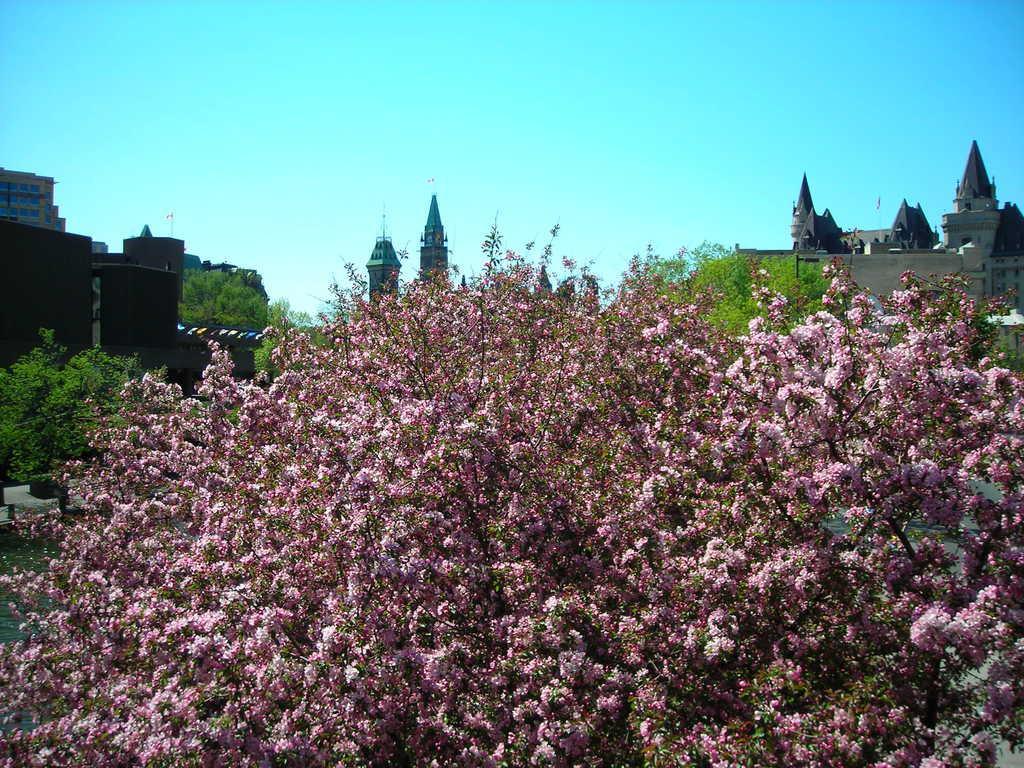Could you give a brief overview of what you see in this image? In the middle of the image we can see some trees. Behind the trees there are some buildings. At the top of the image there is sky. 